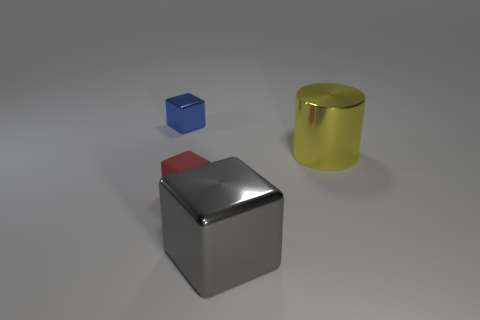Add 1 big cyan objects. How many objects exist? 5 Subtract all blocks. How many objects are left? 1 Subtract 1 blue cubes. How many objects are left? 3 Subtract all tiny red metallic spheres. Subtract all tiny red matte blocks. How many objects are left? 3 Add 3 red matte objects. How many red matte objects are left? 4 Add 3 tiny rubber objects. How many tiny rubber objects exist? 4 